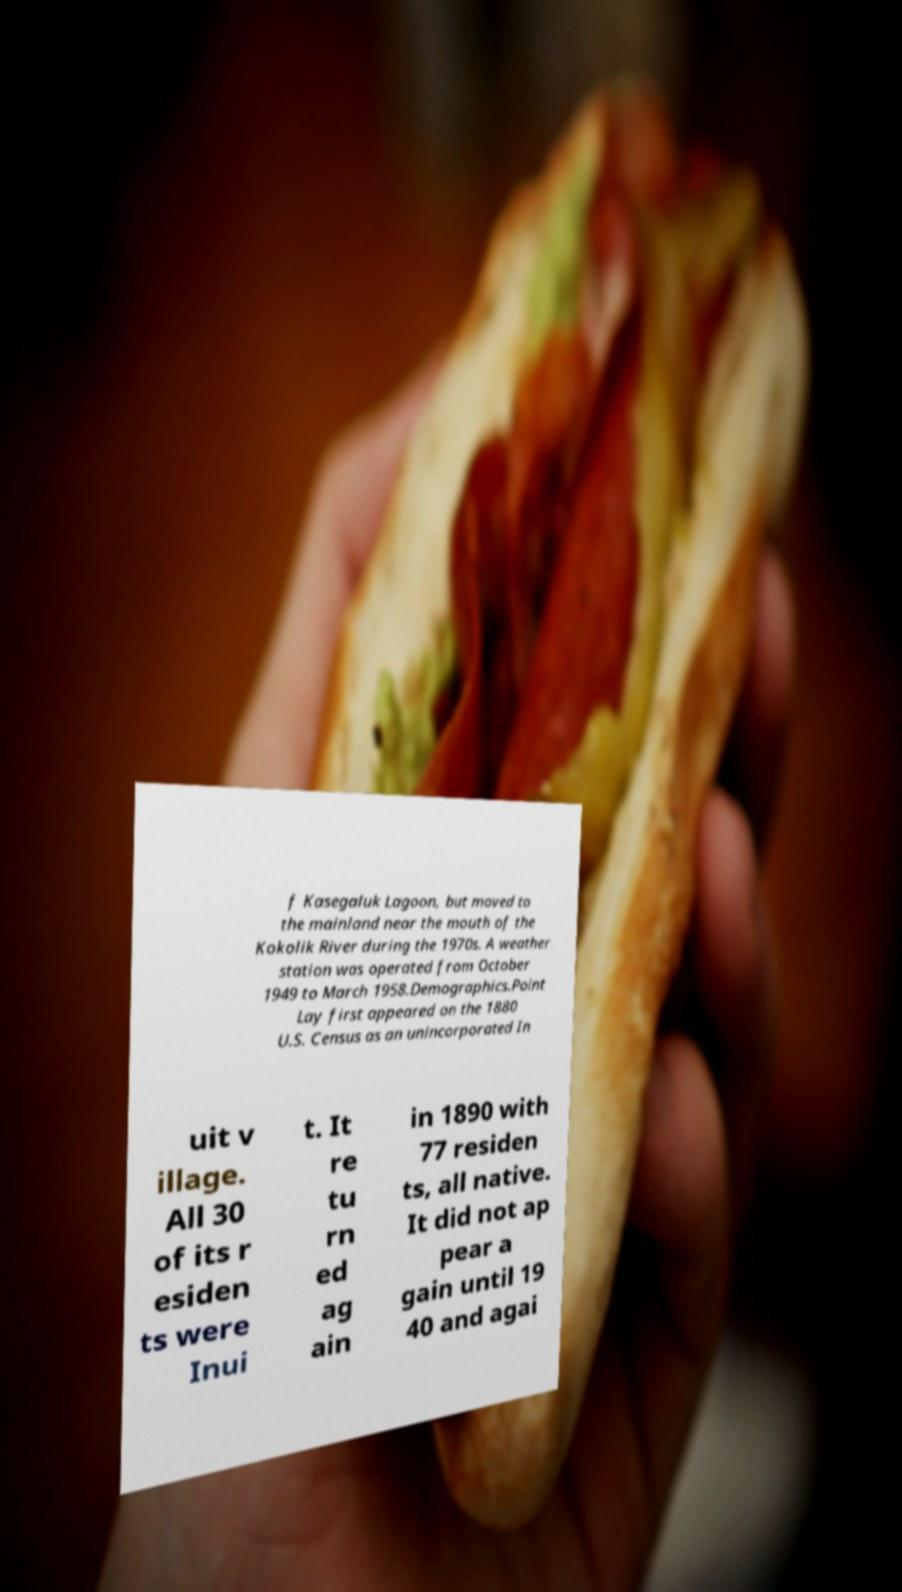Please read and relay the text visible in this image. What does it say? f Kasegaluk Lagoon, but moved to the mainland near the mouth of the Kokolik River during the 1970s. A weather station was operated from October 1949 to March 1958.Demographics.Point Lay first appeared on the 1880 U.S. Census as an unincorporated In uit v illage. All 30 of its r esiden ts were Inui t. It re tu rn ed ag ain in 1890 with 77 residen ts, all native. It did not ap pear a gain until 19 40 and agai 